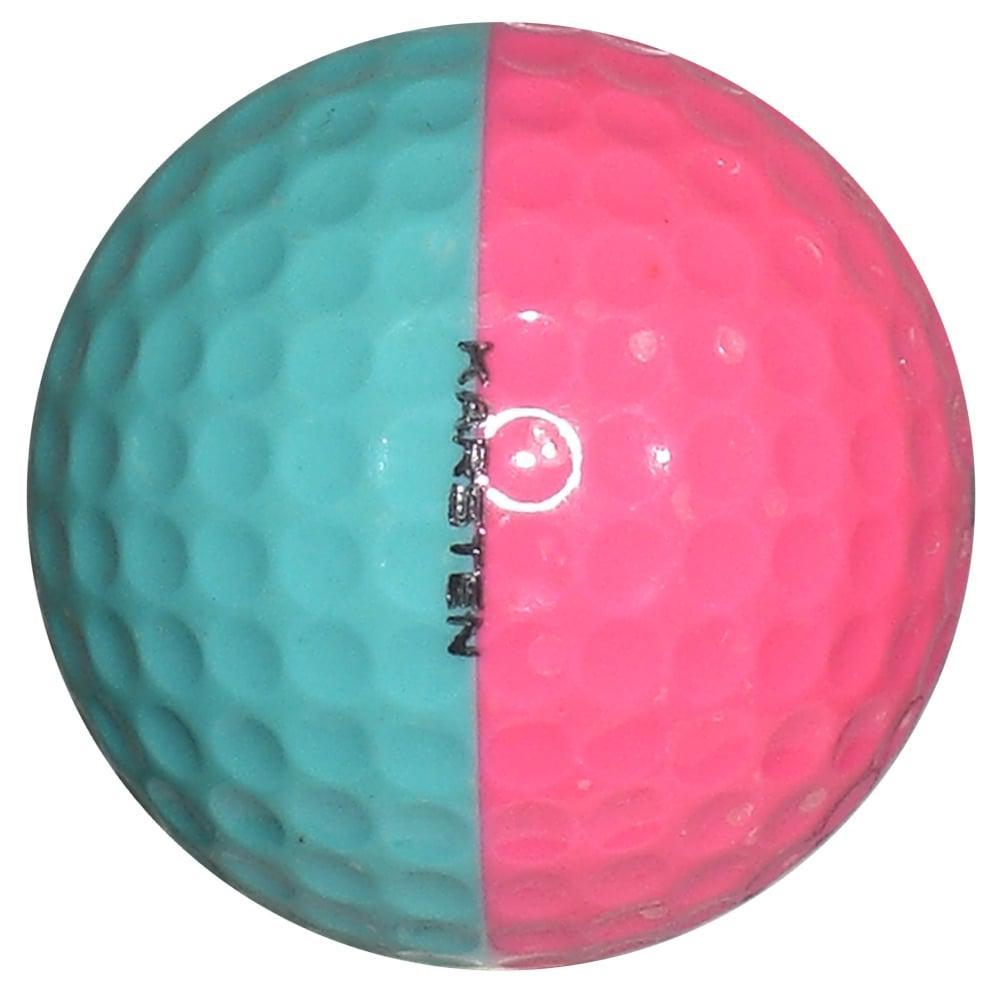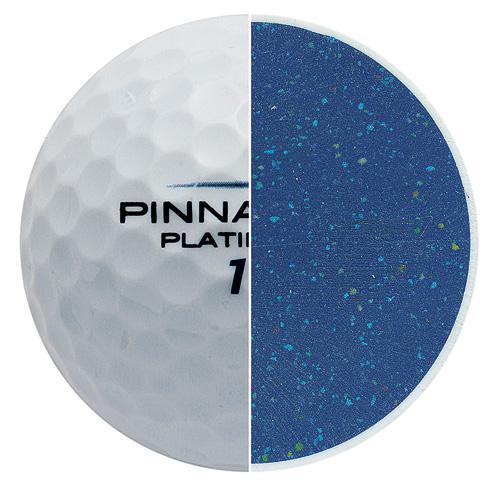The first image is the image on the left, the second image is the image on the right. Analyze the images presented: Is the assertion "One of the balls is two different colors." valid? Answer yes or no. Yes. The first image is the image on the left, the second image is the image on the right. Given the left and right images, does the statement "An image shows a golf ball bisected vertically, with its blue interior showing on the right side of the ball." hold true? Answer yes or no. Yes. 